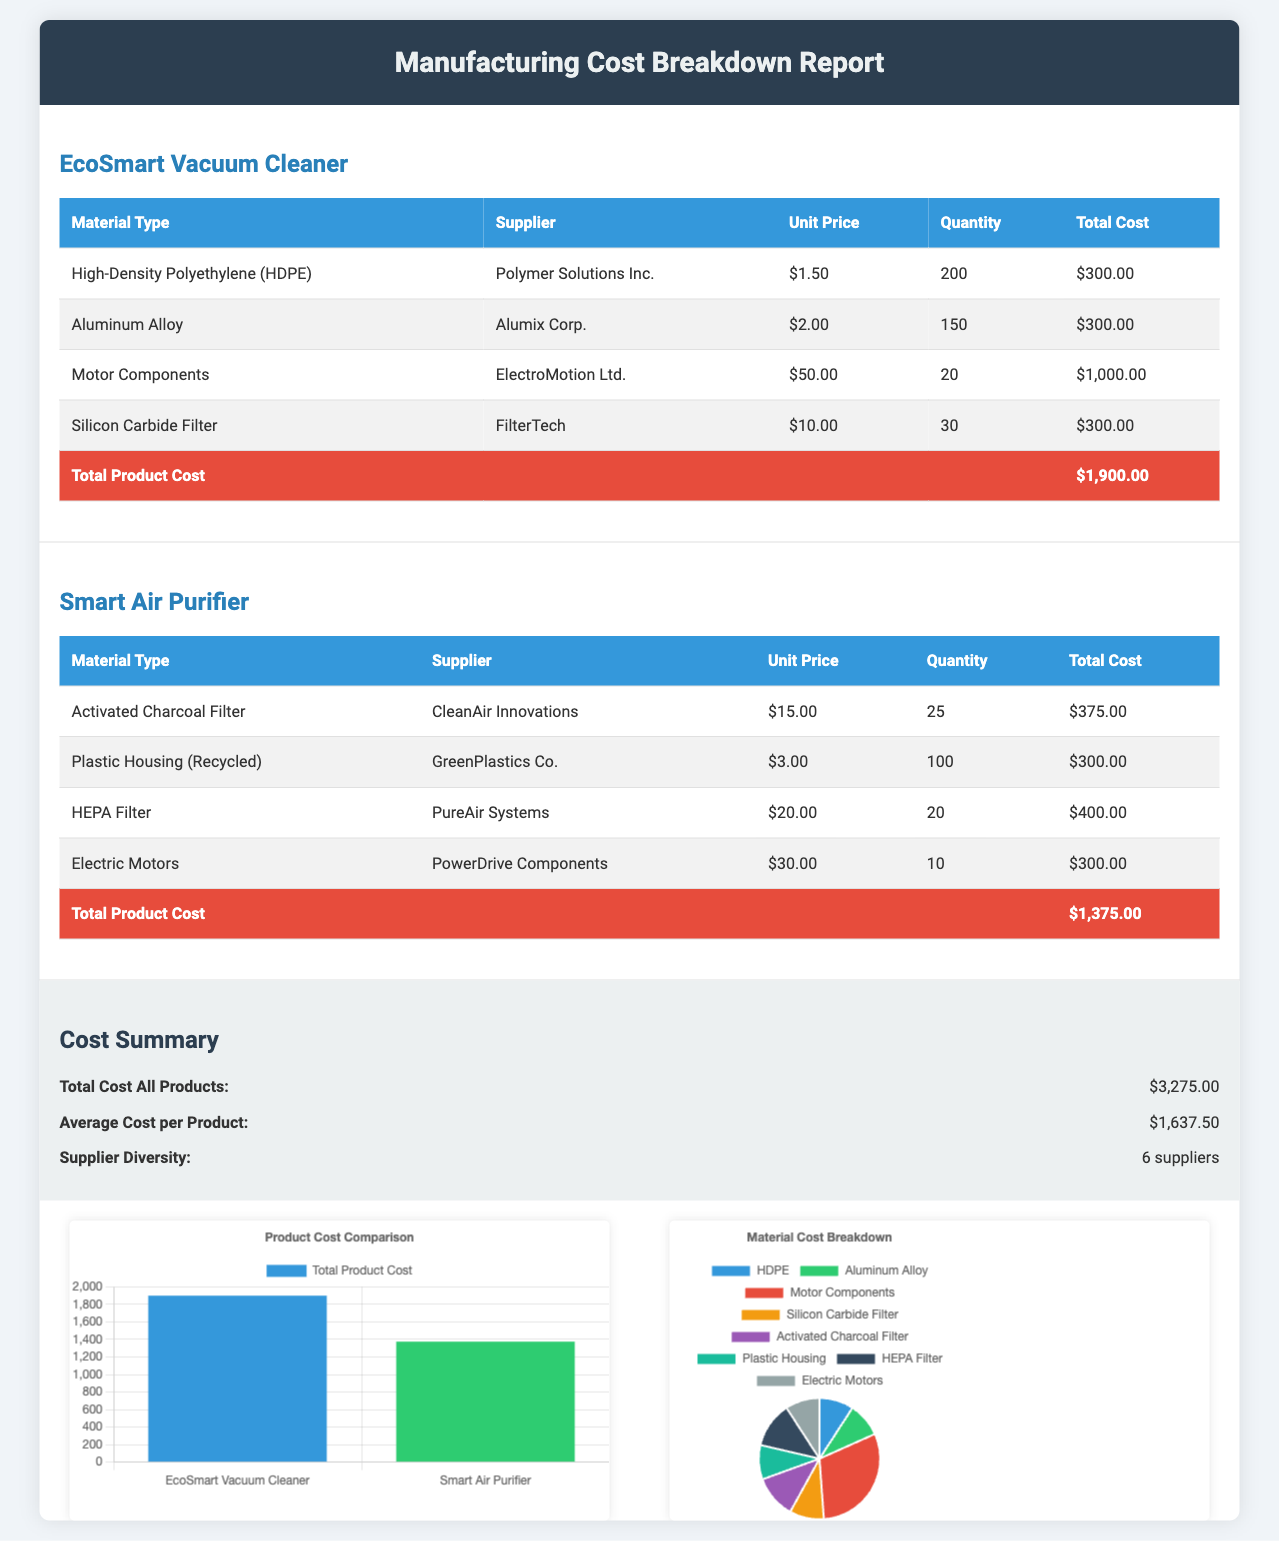what is the total cost of the EcoSmart Vacuum Cleaner? The total cost for the EcoSmart Vacuum Cleaner can be found in the table, which states it is $1,900.00.
Answer: $1,900.00 who is the supplier for Motor Components? The supplier for Motor Components is listed as ElectroMotion Ltd.
Answer: ElectroMotion Ltd how many suppliers are listed in the document? The document states there are 6 suppliers mentioned in the summary section.
Answer: 6 suppliers what is the unit price of the HEPA Filter? The unit price for the HEPA Filter can be found in the Smart Air Purifier table, which shows it is $20.00.
Answer: $20.00 which product has the highest total cost? By comparing the total costs of both products listed, the EcoSmart Vacuum Cleaner has the highest total cost of $1,900.00.
Answer: EcoSmart Vacuum Cleaner what is the total cost for all products? The total cost for all products is given in the summary section, which adds up to $3,275.00.
Answer: $3,275.00 how many units of activated charcoal filter were purchased? The quantity of activated charcoal filter purchased is noted as 25 units in the Smart Air Purifier table.
Answer: 25 what percentage of the total cost does the Aluminum Alloy represent? The total cost of the EcoSmart Vacuum Cleaner is $1,900.00, and the cost of the Aluminum Alloy is $300.00, making it approximately 16% of the total cost.
Answer: 16% what is the average cost per product? The average cost per product can be calculated from the total cost, which is $3,275.00 divided by the number of products (2), resulting in $1,637.50.
Answer: $1,637.50 